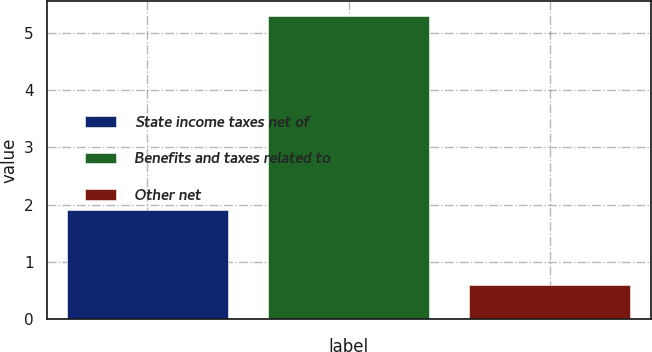Convert chart. <chart><loc_0><loc_0><loc_500><loc_500><bar_chart><fcel>State income taxes net of<fcel>Benefits and taxes related to<fcel>Other net<nl><fcel>1.9<fcel>5.3<fcel>0.6<nl></chart> 